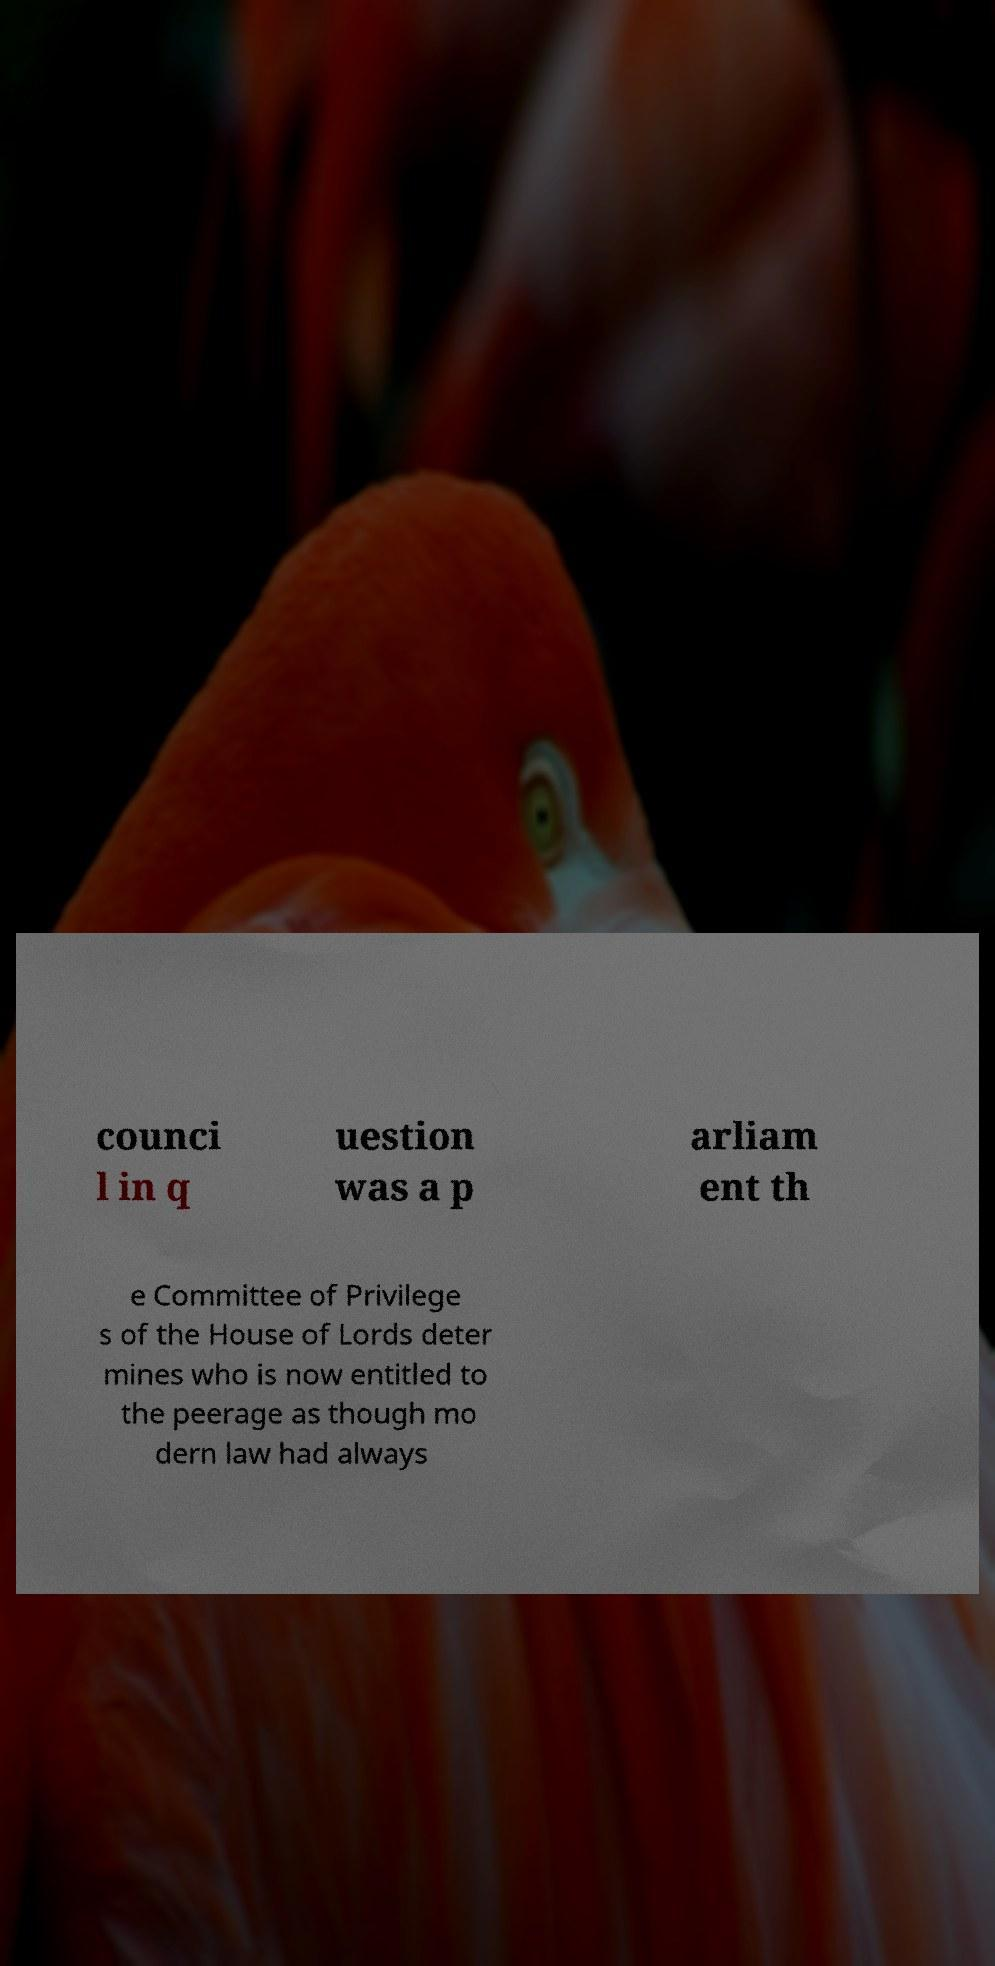What messages or text are displayed in this image? I need them in a readable, typed format. counci l in q uestion was a p arliam ent th e Committee of Privilege s of the House of Lords deter mines who is now entitled to the peerage as though mo dern law had always 